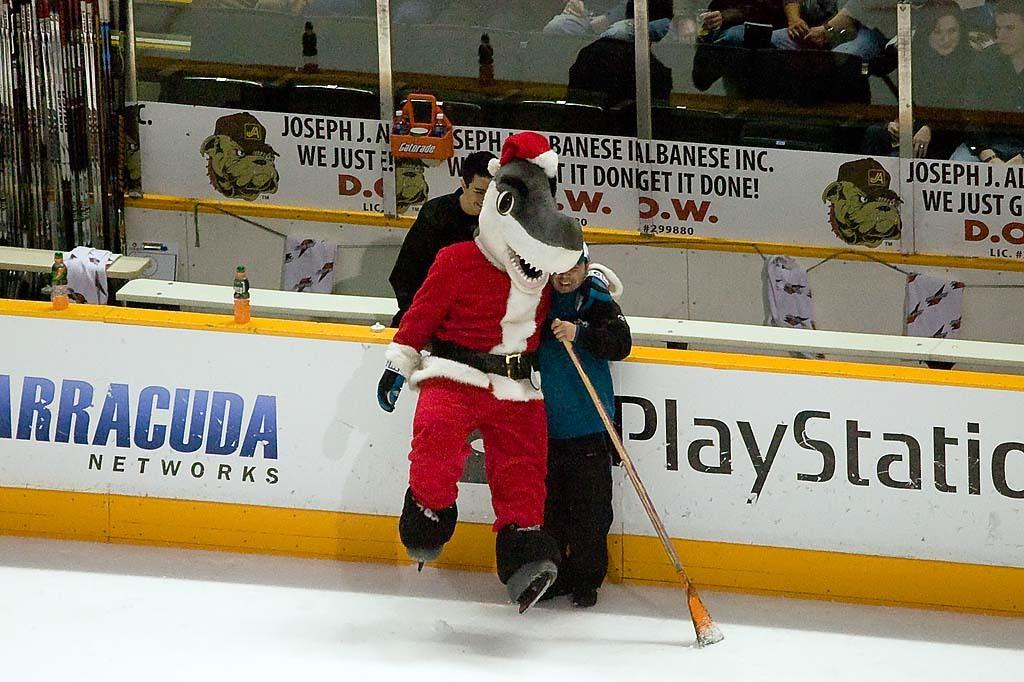<image>
Create a compact narrative representing the image presented. the term PlayStation is on the sign next to the ice 